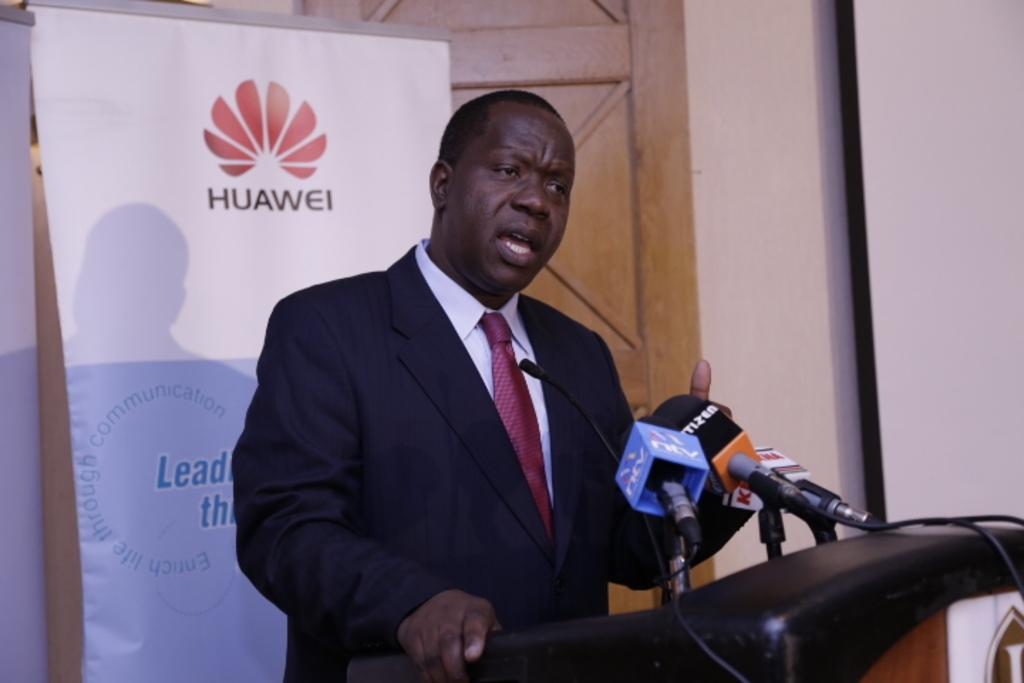What is the man doing at the podium in the image? The man is standing at the podium and talking on the microphones. Where are the microphones located in the image? The microphones are on the podium. What can be seen in the background of the image? There are hoardings, a wall, a door, and a screen in the background. What advice is the man's grandmother giving him before he starts speaking at the podium? There is no mention of a grandmother or any advice in the image. The man is simply standing at the podium and talking on the microphones. What type of desk is visible in the image? There is no desk present in the image. 